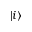Convert formula to latex. <formula><loc_0><loc_0><loc_500><loc_500>| i \rangle</formula> 